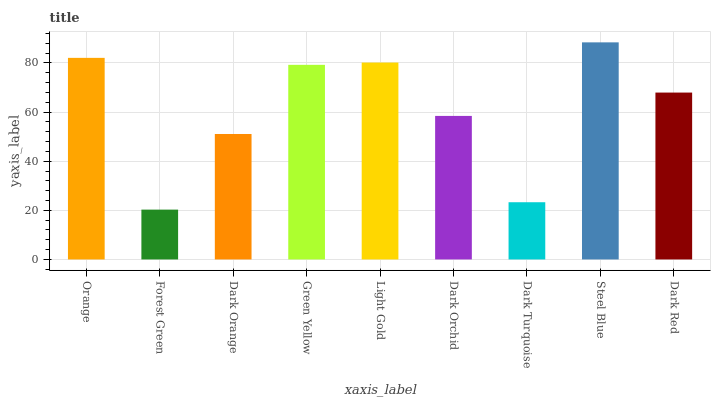Is Forest Green the minimum?
Answer yes or no. Yes. Is Steel Blue the maximum?
Answer yes or no. Yes. Is Dark Orange the minimum?
Answer yes or no. No. Is Dark Orange the maximum?
Answer yes or no. No. Is Dark Orange greater than Forest Green?
Answer yes or no. Yes. Is Forest Green less than Dark Orange?
Answer yes or no. Yes. Is Forest Green greater than Dark Orange?
Answer yes or no. No. Is Dark Orange less than Forest Green?
Answer yes or no. No. Is Dark Red the high median?
Answer yes or no. Yes. Is Dark Red the low median?
Answer yes or no. Yes. Is Green Yellow the high median?
Answer yes or no. No. Is Green Yellow the low median?
Answer yes or no. No. 